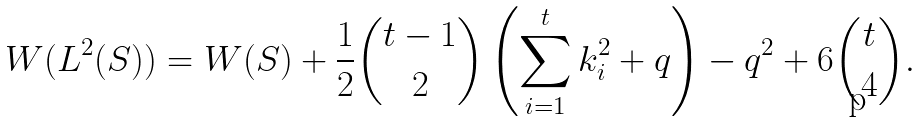Convert formula to latex. <formula><loc_0><loc_0><loc_500><loc_500>W ( L ^ { 2 } ( S ) ) = W ( S ) + \frac { 1 } { 2 } \binom { t - 1 } { 2 } \left ( \sum _ { i = 1 } ^ { t } k _ { i } ^ { 2 } + q \right ) - q ^ { 2 } + 6 \binom { t } { 4 } .</formula> 